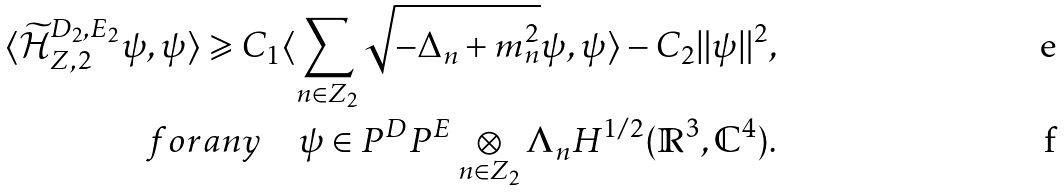<formula> <loc_0><loc_0><loc_500><loc_500>\langle \widetilde { \mathcal { H } } _ { Z , 2 } ^ { D _ { 2 } , E _ { 2 } } \psi , \psi \rangle \geqslant C _ { 1 } \langle \sum _ { n \in Z _ { 2 } } \sqrt { - \Delta _ { n } + m _ { n } ^ { 2 } } \psi , \psi \rangle - C _ { 2 } \| \psi \| ^ { 2 } , \\ f o r a n y \quad \psi \in P ^ { D } P ^ { E } \underset { n \in Z _ { 2 } } { \otimes } \Lambda _ { n } H ^ { 1 / 2 } ( \mathbb { R } ^ { 3 } , \mathbb { C } ^ { 4 } ) .</formula> 